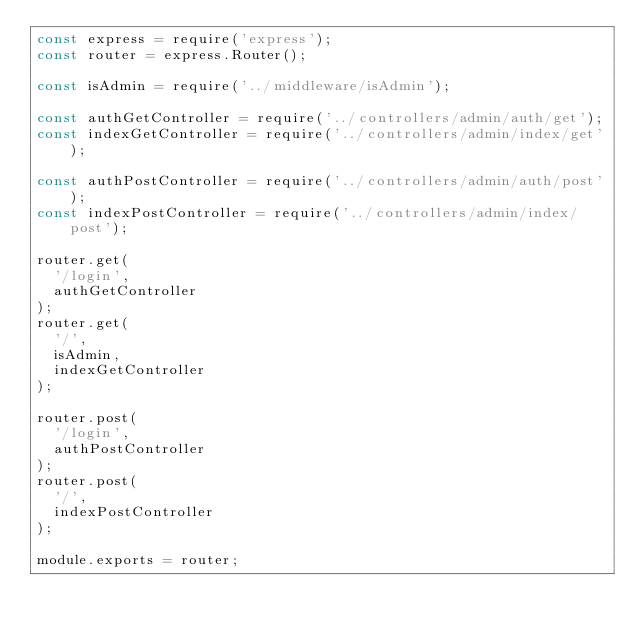<code> <loc_0><loc_0><loc_500><loc_500><_JavaScript_>const express = require('express');
const router = express.Router();

const isAdmin = require('../middleware/isAdmin');

const authGetController = require('../controllers/admin/auth/get');
const indexGetController = require('../controllers/admin/index/get');

const authPostController = require('../controllers/admin/auth/post');
const indexPostController = require('../controllers/admin/index/post');

router.get(
  '/login',
  authGetController
);
router.get(
  '/',
  isAdmin,
  indexGetController
);

router.post(
  '/login',
  authPostController
);
router.post(
  '/',
  indexPostController
);

module.exports = router;
</code> 